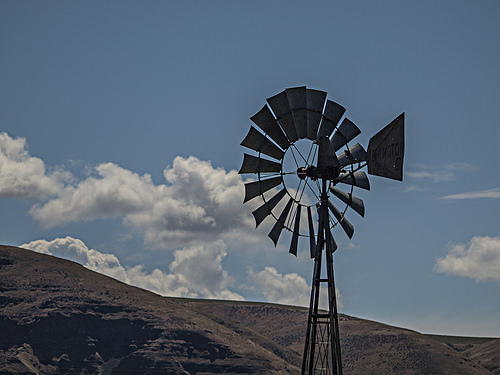<image>
Is there a mountain in front of the sky? Yes. The mountain is positioned in front of the sky, appearing closer to the camera viewpoint. 